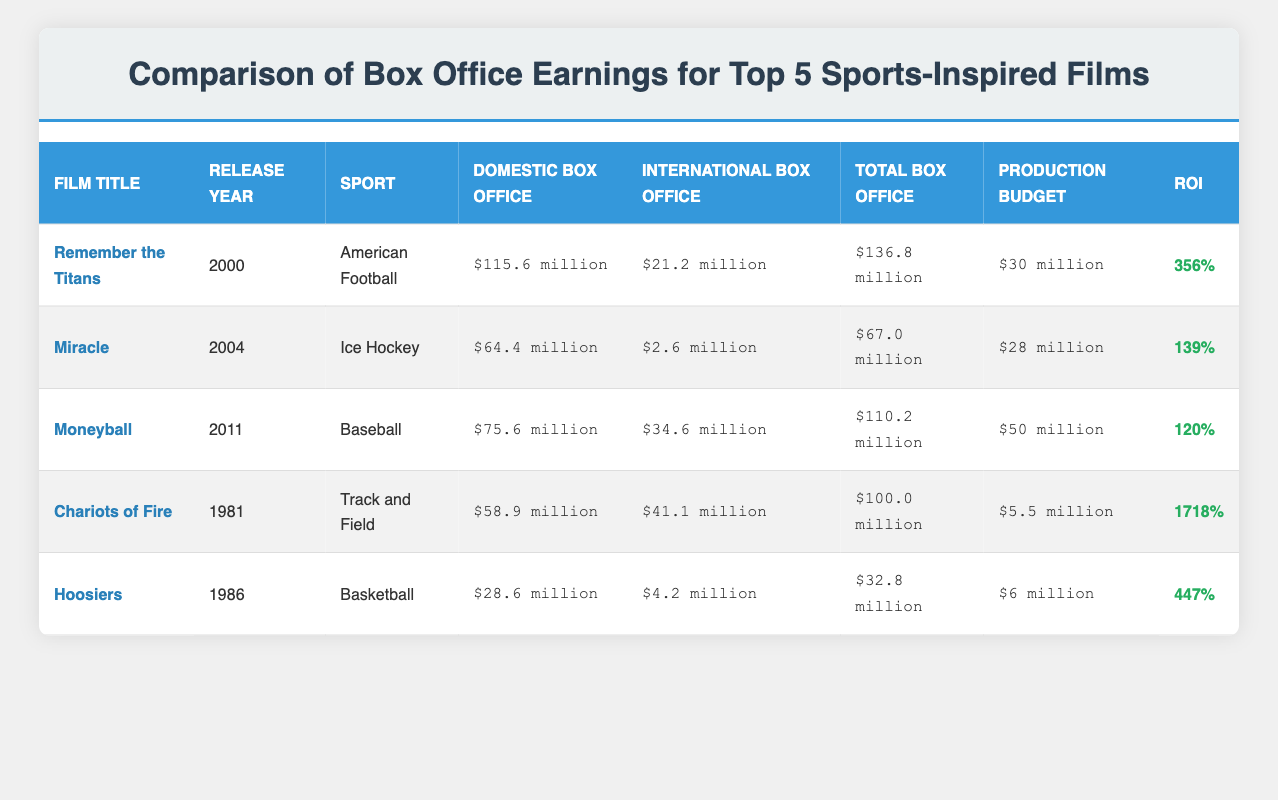What is the total box office earning for "Remember the Titans"? Based on the table, the total box office earning for "Remember the Titans" is listed as $136.8 million.
Answer: $136.8 million Which film has the highest return on investment (ROI)? By comparing the ROI values in the table, "Chariots of Fire" has the highest ROI at 1718%.
Answer: 1718% How much did "Moneyball" earn domestically compared to its production budget? "Moneyball" earned $75.6 million domestically, and its production budget was $50 million. To find the difference, subtract the production budget from the domestic earnings: $75.6 million - $50 million = $25.6 million.
Answer: $25.6 million Did "Hoosiers" earn more internationally than "Miracle"? "Hoosiers" earned $4.2 million internationally while "Miracle" earned $2.6 million. Since $4.2 million is greater than $2.6 million, the answer is yes.
Answer: Yes What is the average total box office of all five films? To find the average, first sum the total box office earnings: $136.8 million + $67.0 million + $110.2 million + $100.0 million + $32.8 million = $446.8 million. Then, divide this total by the number of films (5). The average total box office is $446.8 million / 5 = $89.36 million.
Answer: $89.36 million Which sport inspired the film with the lowest domestic box office earnings? Looking at the table, "Hoosiers," which is a basketball film, has the lowest domestic box office earnings of $28.6 million.
Answer: Basketball What percentage of its total box office did "Miracle" earn from domestic earnings? "Miracle" earned $64.4 million domestically out of a total box office of $67.0 million. To find the percentage, divide the domestic earnings by the total: ($64.4 million / $67.0 million) * 100 ≈ 96.6%.
Answer: 96.6% How much greater is the total box office of "Remember the Titans" compared to "Hoosiers"? "Remember the Titans" has a total box office of $136.8 million and "Hoosiers" has $32.8 million. To find the difference, subtract: $136.8 million - $32.8 million = $104 million.
Answer: $104 million 